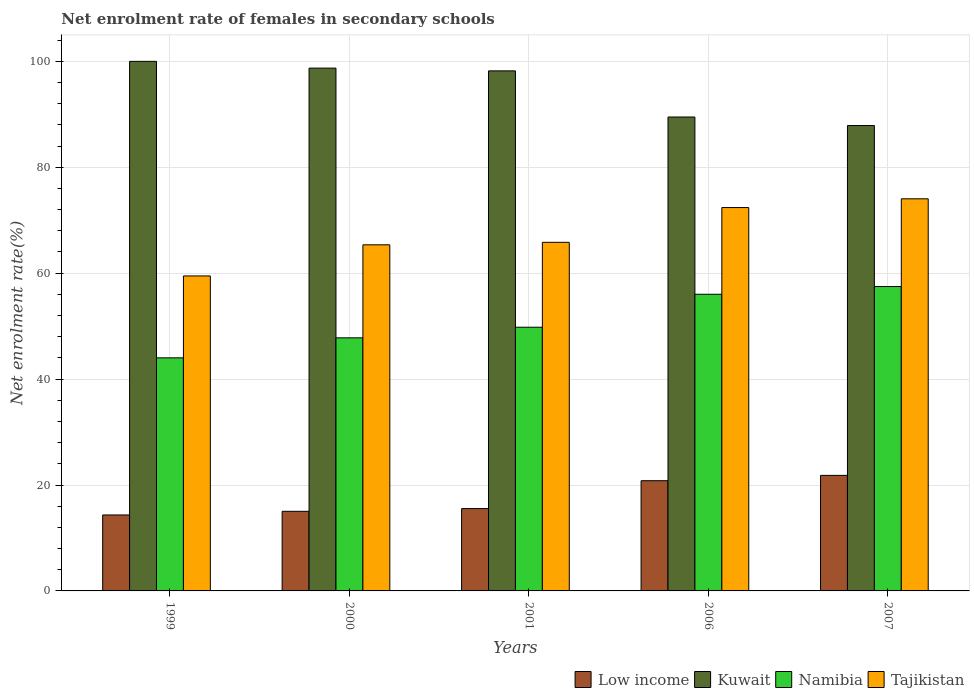How many groups of bars are there?
Make the answer very short. 5. Are the number of bars per tick equal to the number of legend labels?
Keep it short and to the point. Yes. How many bars are there on the 5th tick from the right?
Your answer should be compact. 4. In how many cases, is the number of bars for a given year not equal to the number of legend labels?
Your answer should be compact. 0. What is the net enrolment rate of females in secondary schools in Kuwait in 2006?
Ensure brevity in your answer.  89.49. Across all years, what is the maximum net enrolment rate of females in secondary schools in Namibia?
Keep it short and to the point. 57.48. Across all years, what is the minimum net enrolment rate of females in secondary schools in Kuwait?
Keep it short and to the point. 87.88. In which year was the net enrolment rate of females in secondary schools in Low income maximum?
Provide a succinct answer. 2007. In which year was the net enrolment rate of females in secondary schools in Kuwait minimum?
Offer a very short reply. 2007. What is the total net enrolment rate of females in secondary schools in Tajikistan in the graph?
Your answer should be very brief. 337.1. What is the difference between the net enrolment rate of females in secondary schools in Kuwait in 2001 and that in 2007?
Make the answer very short. 10.32. What is the difference between the net enrolment rate of females in secondary schools in Tajikistan in 2000 and the net enrolment rate of females in secondary schools in Namibia in 2006?
Provide a short and direct response. 9.34. What is the average net enrolment rate of females in secondary schools in Low income per year?
Ensure brevity in your answer.  17.51. In the year 2001, what is the difference between the net enrolment rate of females in secondary schools in Kuwait and net enrolment rate of females in secondary schools in Namibia?
Your answer should be compact. 48.41. In how many years, is the net enrolment rate of females in secondary schools in Namibia greater than 72 %?
Your answer should be very brief. 0. What is the ratio of the net enrolment rate of females in secondary schools in Kuwait in 2000 to that in 2007?
Give a very brief answer. 1.12. What is the difference between the highest and the second highest net enrolment rate of females in secondary schools in Low income?
Your response must be concise. 1.01. What is the difference between the highest and the lowest net enrolment rate of females in secondary schools in Low income?
Give a very brief answer. 7.47. What does the 2nd bar from the left in 2007 represents?
Your answer should be very brief. Kuwait. What does the 1st bar from the right in 2006 represents?
Provide a short and direct response. Tajikistan. How many bars are there?
Offer a terse response. 20. Are all the bars in the graph horizontal?
Provide a succinct answer. No. How many years are there in the graph?
Make the answer very short. 5. Where does the legend appear in the graph?
Provide a succinct answer. Bottom right. How are the legend labels stacked?
Your answer should be very brief. Horizontal. What is the title of the graph?
Provide a succinct answer. Net enrolment rate of females in secondary schools. What is the label or title of the Y-axis?
Your response must be concise. Net enrolment rate(%). What is the Net enrolment rate(%) of Low income in 1999?
Provide a succinct answer. 14.35. What is the Net enrolment rate(%) in Kuwait in 1999?
Offer a terse response. 100. What is the Net enrolment rate(%) of Namibia in 1999?
Your response must be concise. 44.01. What is the Net enrolment rate(%) of Tajikistan in 1999?
Offer a terse response. 59.48. What is the Net enrolment rate(%) in Low income in 2000?
Offer a terse response. 15.03. What is the Net enrolment rate(%) of Kuwait in 2000?
Offer a terse response. 98.72. What is the Net enrolment rate(%) in Namibia in 2000?
Ensure brevity in your answer.  47.79. What is the Net enrolment rate(%) in Tajikistan in 2000?
Ensure brevity in your answer.  65.36. What is the Net enrolment rate(%) in Low income in 2001?
Make the answer very short. 15.55. What is the Net enrolment rate(%) of Kuwait in 2001?
Your answer should be very brief. 98.2. What is the Net enrolment rate(%) in Namibia in 2001?
Provide a succinct answer. 49.79. What is the Net enrolment rate(%) of Tajikistan in 2001?
Provide a succinct answer. 65.83. What is the Net enrolment rate(%) of Low income in 2006?
Ensure brevity in your answer.  20.81. What is the Net enrolment rate(%) of Kuwait in 2006?
Make the answer very short. 89.49. What is the Net enrolment rate(%) in Namibia in 2006?
Make the answer very short. 56.02. What is the Net enrolment rate(%) in Tajikistan in 2006?
Your answer should be compact. 72.39. What is the Net enrolment rate(%) in Low income in 2007?
Your answer should be compact. 21.82. What is the Net enrolment rate(%) in Kuwait in 2007?
Your answer should be very brief. 87.88. What is the Net enrolment rate(%) in Namibia in 2007?
Ensure brevity in your answer.  57.48. What is the Net enrolment rate(%) in Tajikistan in 2007?
Give a very brief answer. 74.05. Across all years, what is the maximum Net enrolment rate(%) in Low income?
Give a very brief answer. 21.82. Across all years, what is the maximum Net enrolment rate(%) in Namibia?
Offer a very short reply. 57.48. Across all years, what is the maximum Net enrolment rate(%) in Tajikistan?
Your answer should be very brief. 74.05. Across all years, what is the minimum Net enrolment rate(%) of Low income?
Your answer should be compact. 14.35. Across all years, what is the minimum Net enrolment rate(%) of Kuwait?
Keep it short and to the point. 87.88. Across all years, what is the minimum Net enrolment rate(%) in Namibia?
Your answer should be very brief. 44.01. Across all years, what is the minimum Net enrolment rate(%) in Tajikistan?
Your answer should be compact. 59.48. What is the total Net enrolment rate(%) of Low income in the graph?
Your answer should be very brief. 87.56. What is the total Net enrolment rate(%) of Kuwait in the graph?
Give a very brief answer. 474.3. What is the total Net enrolment rate(%) in Namibia in the graph?
Offer a terse response. 255.1. What is the total Net enrolment rate(%) of Tajikistan in the graph?
Offer a very short reply. 337.1. What is the difference between the Net enrolment rate(%) in Low income in 1999 and that in 2000?
Your answer should be very brief. -0.69. What is the difference between the Net enrolment rate(%) of Kuwait in 1999 and that in 2000?
Provide a short and direct response. 1.28. What is the difference between the Net enrolment rate(%) of Namibia in 1999 and that in 2000?
Provide a succinct answer. -3.78. What is the difference between the Net enrolment rate(%) of Tajikistan in 1999 and that in 2000?
Provide a short and direct response. -5.88. What is the difference between the Net enrolment rate(%) of Low income in 1999 and that in 2001?
Offer a terse response. -1.2. What is the difference between the Net enrolment rate(%) in Kuwait in 1999 and that in 2001?
Provide a succinct answer. 1.8. What is the difference between the Net enrolment rate(%) in Namibia in 1999 and that in 2001?
Your answer should be very brief. -5.78. What is the difference between the Net enrolment rate(%) in Tajikistan in 1999 and that in 2001?
Your answer should be compact. -6.35. What is the difference between the Net enrolment rate(%) of Low income in 1999 and that in 2006?
Your response must be concise. -6.47. What is the difference between the Net enrolment rate(%) of Kuwait in 1999 and that in 2006?
Make the answer very short. 10.51. What is the difference between the Net enrolment rate(%) in Namibia in 1999 and that in 2006?
Your answer should be very brief. -12. What is the difference between the Net enrolment rate(%) in Tajikistan in 1999 and that in 2006?
Your answer should be compact. -12.91. What is the difference between the Net enrolment rate(%) in Low income in 1999 and that in 2007?
Your response must be concise. -7.47. What is the difference between the Net enrolment rate(%) of Kuwait in 1999 and that in 2007?
Offer a very short reply. 12.12. What is the difference between the Net enrolment rate(%) of Namibia in 1999 and that in 2007?
Your answer should be very brief. -13.46. What is the difference between the Net enrolment rate(%) in Tajikistan in 1999 and that in 2007?
Your answer should be very brief. -14.57. What is the difference between the Net enrolment rate(%) in Low income in 2000 and that in 2001?
Your answer should be compact. -0.52. What is the difference between the Net enrolment rate(%) of Kuwait in 2000 and that in 2001?
Give a very brief answer. 0.52. What is the difference between the Net enrolment rate(%) in Namibia in 2000 and that in 2001?
Keep it short and to the point. -2. What is the difference between the Net enrolment rate(%) of Tajikistan in 2000 and that in 2001?
Make the answer very short. -0.47. What is the difference between the Net enrolment rate(%) of Low income in 2000 and that in 2006?
Give a very brief answer. -5.78. What is the difference between the Net enrolment rate(%) in Kuwait in 2000 and that in 2006?
Keep it short and to the point. 9.23. What is the difference between the Net enrolment rate(%) in Namibia in 2000 and that in 2006?
Your answer should be very brief. -8.23. What is the difference between the Net enrolment rate(%) of Tajikistan in 2000 and that in 2006?
Your answer should be very brief. -7.04. What is the difference between the Net enrolment rate(%) of Low income in 2000 and that in 2007?
Keep it short and to the point. -6.79. What is the difference between the Net enrolment rate(%) in Kuwait in 2000 and that in 2007?
Your answer should be compact. 10.84. What is the difference between the Net enrolment rate(%) in Namibia in 2000 and that in 2007?
Make the answer very short. -9.68. What is the difference between the Net enrolment rate(%) in Tajikistan in 2000 and that in 2007?
Your answer should be compact. -8.69. What is the difference between the Net enrolment rate(%) in Low income in 2001 and that in 2006?
Keep it short and to the point. -5.26. What is the difference between the Net enrolment rate(%) of Kuwait in 2001 and that in 2006?
Provide a short and direct response. 8.71. What is the difference between the Net enrolment rate(%) of Namibia in 2001 and that in 2006?
Offer a terse response. -6.22. What is the difference between the Net enrolment rate(%) of Tajikistan in 2001 and that in 2006?
Provide a succinct answer. -6.56. What is the difference between the Net enrolment rate(%) in Low income in 2001 and that in 2007?
Ensure brevity in your answer.  -6.27. What is the difference between the Net enrolment rate(%) in Kuwait in 2001 and that in 2007?
Offer a terse response. 10.32. What is the difference between the Net enrolment rate(%) in Namibia in 2001 and that in 2007?
Your response must be concise. -7.68. What is the difference between the Net enrolment rate(%) in Tajikistan in 2001 and that in 2007?
Ensure brevity in your answer.  -8.22. What is the difference between the Net enrolment rate(%) of Low income in 2006 and that in 2007?
Offer a very short reply. -1.01. What is the difference between the Net enrolment rate(%) in Kuwait in 2006 and that in 2007?
Provide a short and direct response. 1.61. What is the difference between the Net enrolment rate(%) of Namibia in 2006 and that in 2007?
Provide a succinct answer. -1.46. What is the difference between the Net enrolment rate(%) in Tajikistan in 2006 and that in 2007?
Your response must be concise. -1.65. What is the difference between the Net enrolment rate(%) in Low income in 1999 and the Net enrolment rate(%) in Kuwait in 2000?
Offer a very short reply. -84.38. What is the difference between the Net enrolment rate(%) in Low income in 1999 and the Net enrolment rate(%) in Namibia in 2000?
Your answer should be compact. -33.45. What is the difference between the Net enrolment rate(%) in Low income in 1999 and the Net enrolment rate(%) in Tajikistan in 2000?
Your answer should be compact. -51.01. What is the difference between the Net enrolment rate(%) of Kuwait in 1999 and the Net enrolment rate(%) of Namibia in 2000?
Offer a terse response. 52.21. What is the difference between the Net enrolment rate(%) in Kuwait in 1999 and the Net enrolment rate(%) in Tajikistan in 2000?
Keep it short and to the point. 34.65. What is the difference between the Net enrolment rate(%) in Namibia in 1999 and the Net enrolment rate(%) in Tajikistan in 2000?
Your response must be concise. -21.34. What is the difference between the Net enrolment rate(%) of Low income in 1999 and the Net enrolment rate(%) of Kuwait in 2001?
Offer a terse response. -83.86. What is the difference between the Net enrolment rate(%) of Low income in 1999 and the Net enrolment rate(%) of Namibia in 2001?
Provide a succinct answer. -35.45. What is the difference between the Net enrolment rate(%) in Low income in 1999 and the Net enrolment rate(%) in Tajikistan in 2001?
Your response must be concise. -51.48. What is the difference between the Net enrolment rate(%) of Kuwait in 1999 and the Net enrolment rate(%) of Namibia in 2001?
Keep it short and to the point. 50.21. What is the difference between the Net enrolment rate(%) of Kuwait in 1999 and the Net enrolment rate(%) of Tajikistan in 2001?
Give a very brief answer. 34.17. What is the difference between the Net enrolment rate(%) in Namibia in 1999 and the Net enrolment rate(%) in Tajikistan in 2001?
Your answer should be compact. -21.81. What is the difference between the Net enrolment rate(%) in Low income in 1999 and the Net enrolment rate(%) in Kuwait in 2006?
Keep it short and to the point. -75.15. What is the difference between the Net enrolment rate(%) of Low income in 1999 and the Net enrolment rate(%) of Namibia in 2006?
Provide a succinct answer. -41.67. What is the difference between the Net enrolment rate(%) in Low income in 1999 and the Net enrolment rate(%) in Tajikistan in 2006?
Offer a very short reply. -58.05. What is the difference between the Net enrolment rate(%) of Kuwait in 1999 and the Net enrolment rate(%) of Namibia in 2006?
Keep it short and to the point. 43.98. What is the difference between the Net enrolment rate(%) in Kuwait in 1999 and the Net enrolment rate(%) in Tajikistan in 2006?
Provide a succinct answer. 27.61. What is the difference between the Net enrolment rate(%) of Namibia in 1999 and the Net enrolment rate(%) of Tajikistan in 2006?
Provide a short and direct response. -28.38. What is the difference between the Net enrolment rate(%) in Low income in 1999 and the Net enrolment rate(%) in Kuwait in 2007?
Your response must be concise. -73.54. What is the difference between the Net enrolment rate(%) in Low income in 1999 and the Net enrolment rate(%) in Namibia in 2007?
Keep it short and to the point. -43.13. What is the difference between the Net enrolment rate(%) of Low income in 1999 and the Net enrolment rate(%) of Tajikistan in 2007?
Make the answer very short. -59.7. What is the difference between the Net enrolment rate(%) of Kuwait in 1999 and the Net enrolment rate(%) of Namibia in 2007?
Give a very brief answer. 42.52. What is the difference between the Net enrolment rate(%) in Kuwait in 1999 and the Net enrolment rate(%) in Tajikistan in 2007?
Ensure brevity in your answer.  25.95. What is the difference between the Net enrolment rate(%) in Namibia in 1999 and the Net enrolment rate(%) in Tajikistan in 2007?
Your answer should be very brief. -30.03. What is the difference between the Net enrolment rate(%) of Low income in 2000 and the Net enrolment rate(%) of Kuwait in 2001?
Your answer should be very brief. -83.17. What is the difference between the Net enrolment rate(%) in Low income in 2000 and the Net enrolment rate(%) in Namibia in 2001?
Your answer should be compact. -34.76. What is the difference between the Net enrolment rate(%) of Low income in 2000 and the Net enrolment rate(%) of Tajikistan in 2001?
Provide a succinct answer. -50.79. What is the difference between the Net enrolment rate(%) in Kuwait in 2000 and the Net enrolment rate(%) in Namibia in 2001?
Ensure brevity in your answer.  48.93. What is the difference between the Net enrolment rate(%) of Kuwait in 2000 and the Net enrolment rate(%) of Tajikistan in 2001?
Provide a short and direct response. 32.9. What is the difference between the Net enrolment rate(%) of Namibia in 2000 and the Net enrolment rate(%) of Tajikistan in 2001?
Provide a succinct answer. -18.04. What is the difference between the Net enrolment rate(%) of Low income in 2000 and the Net enrolment rate(%) of Kuwait in 2006?
Provide a succinct answer. -74.46. What is the difference between the Net enrolment rate(%) in Low income in 2000 and the Net enrolment rate(%) in Namibia in 2006?
Offer a very short reply. -40.99. What is the difference between the Net enrolment rate(%) in Low income in 2000 and the Net enrolment rate(%) in Tajikistan in 2006?
Keep it short and to the point. -57.36. What is the difference between the Net enrolment rate(%) in Kuwait in 2000 and the Net enrolment rate(%) in Namibia in 2006?
Your response must be concise. 42.7. What is the difference between the Net enrolment rate(%) of Kuwait in 2000 and the Net enrolment rate(%) of Tajikistan in 2006?
Offer a terse response. 26.33. What is the difference between the Net enrolment rate(%) in Namibia in 2000 and the Net enrolment rate(%) in Tajikistan in 2006?
Provide a short and direct response. -24.6. What is the difference between the Net enrolment rate(%) of Low income in 2000 and the Net enrolment rate(%) of Kuwait in 2007?
Your response must be concise. -72.85. What is the difference between the Net enrolment rate(%) in Low income in 2000 and the Net enrolment rate(%) in Namibia in 2007?
Offer a very short reply. -42.44. What is the difference between the Net enrolment rate(%) of Low income in 2000 and the Net enrolment rate(%) of Tajikistan in 2007?
Offer a terse response. -59.01. What is the difference between the Net enrolment rate(%) in Kuwait in 2000 and the Net enrolment rate(%) in Namibia in 2007?
Your answer should be very brief. 41.25. What is the difference between the Net enrolment rate(%) of Kuwait in 2000 and the Net enrolment rate(%) of Tajikistan in 2007?
Offer a very short reply. 24.68. What is the difference between the Net enrolment rate(%) in Namibia in 2000 and the Net enrolment rate(%) in Tajikistan in 2007?
Keep it short and to the point. -26.25. What is the difference between the Net enrolment rate(%) of Low income in 2001 and the Net enrolment rate(%) of Kuwait in 2006?
Offer a terse response. -73.94. What is the difference between the Net enrolment rate(%) of Low income in 2001 and the Net enrolment rate(%) of Namibia in 2006?
Make the answer very short. -40.47. What is the difference between the Net enrolment rate(%) of Low income in 2001 and the Net enrolment rate(%) of Tajikistan in 2006?
Make the answer very short. -56.84. What is the difference between the Net enrolment rate(%) of Kuwait in 2001 and the Net enrolment rate(%) of Namibia in 2006?
Give a very brief answer. 42.18. What is the difference between the Net enrolment rate(%) of Kuwait in 2001 and the Net enrolment rate(%) of Tajikistan in 2006?
Your answer should be very brief. 25.81. What is the difference between the Net enrolment rate(%) of Namibia in 2001 and the Net enrolment rate(%) of Tajikistan in 2006?
Ensure brevity in your answer.  -22.6. What is the difference between the Net enrolment rate(%) of Low income in 2001 and the Net enrolment rate(%) of Kuwait in 2007?
Keep it short and to the point. -72.33. What is the difference between the Net enrolment rate(%) in Low income in 2001 and the Net enrolment rate(%) in Namibia in 2007?
Ensure brevity in your answer.  -41.93. What is the difference between the Net enrolment rate(%) in Low income in 2001 and the Net enrolment rate(%) in Tajikistan in 2007?
Make the answer very short. -58.5. What is the difference between the Net enrolment rate(%) in Kuwait in 2001 and the Net enrolment rate(%) in Namibia in 2007?
Offer a very short reply. 40.73. What is the difference between the Net enrolment rate(%) in Kuwait in 2001 and the Net enrolment rate(%) in Tajikistan in 2007?
Keep it short and to the point. 24.16. What is the difference between the Net enrolment rate(%) in Namibia in 2001 and the Net enrolment rate(%) in Tajikistan in 2007?
Your response must be concise. -24.25. What is the difference between the Net enrolment rate(%) of Low income in 2006 and the Net enrolment rate(%) of Kuwait in 2007?
Make the answer very short. -67.07. What is the difference between the Net enrolment rate(%) in Low income in 2006 and the Net enrolment rate(%) in Namibia in 2007?
Keep it short and to the point. -36.66. What is the difference between the Net enrolment rate(%) of Low income in 2006 and the Net enrolment rate(%) of Tajikistan in 2007?
Offer a very short reply. -53.23. What is the difference between the Net enrolment rate(%) of Kuwait in 2006 and the Net enrolment rate(%) of Namibia in 2007?
Provide a succinct answer. 32.02. What is the difference between the Net enrolment rate(%) in Kuwait in 2006 and the Net enrolment rate(%) in Tajikistan in 2007?
Ensure brevity in your answer.  15.45. What is the difference between the Net enrolment rate(%) of Namibia in 2006 and the Net enrolment rate(%) of Tajikistan in 2007?
Offer a terse response. -18.03. What is the average Net enrolment rate(%) of Low income per year?
Keep it short and to the point. 17.51. What is the average Net enrolment rate(%) in Kuwait per year?
Keep it short and to the point. 94.86. What is the average Net enrolment rate(%) of Namibia per year?
Your response must be concise. 51.02. What is the average Net enrolment rate(%) of Tajikistan per year?
Give a very brief answer. 67.42. In the year 1999, what is the difference between the Net enrolment rate(%) in Low income and Net enrolment rate(%) in Kuwait?
Offer a terse response. -85.66. In the year 1999, what is the difference between the Net enrolment rate(%) of Low income and Net enrolment rate(%) of Namibia?
Offer a very short reply. -29.67. In the year 1999, what is the difference between the Net enrolment rate(%) of Low income and Net enrolment rate(%) of Tajikistan?
Your answer should be compact. -45.13. In the year 1999, what is the difference between the Net enrolment rate(%) of Kuwait and Net enrolment rate(%) of Namibia?
Make the answer very short. 55.99. In the year 1999, what is the difference between the Net enrolment rate(%) of Kuwait and Net enrolment rate(%) of Tajikistan?
Make the answer very short. 40.52. In the year 1999, what is the difference between the Net enrolment rate(%) in Namibia and Net enrolment rate(%) in Tajikistan?
Your answer should be very brief. -15.46. In the year 2000, what is the difference between the Net enrolment rate(%) of Low income and Net enrolment rate(%) of Kuwait?
Keep it short and to the point. -83.69. In the year 2000, what is the difference between the Net enrolment rate(%) of Low income and Net enrolment rate(%) of Namibia?
Keep it short and to the point. -32.76. In the year 2000, what is the difference between the Net enrolment rate(%) of Low income and Net enrolment rate(%) of Tajikistan?
Make the answer very short. -50.32. In the year 2000, what is the difference between the Net enrolment rate(%) of Kuwait and Net enrolment rate(%) of Namibia?
Your answer should be compact. 50.93. In the year 2000, what is the difference between the Net enrolment rate(%) in Kuwait and Net enrolment rate(%) in Tajikistan?
Offer a terse response. 33.37. In the year 2000, what is the difference between the Net enrolment rate(%) in Namibia and Net enrolment rate(%) in Tajikistan?
Your response must be concise. -17.56. In the year 2001, what is the difference between the Net enrolment rate(%) of Low income and Net enrolment rate(%) of Kuwait?
Your answer should be very brief. -82.65. In the year 2001, what is the difference between the Net enrolment rate(%) in Low income and Net enrolment rate(%) in Namibia?
Offer a terse response. -34.25. In the year 2001, what is the difference between the Net enrolment rate(%) of Low income and Net enrolment rate(%) of Tajikistan?
Provide a succinct answer. -50.28. In the year 2001, what is the difference between the Net enrolment rate(%) in Kuwait and Net enrolment rate(%) in Namibia?
Make the answer very short. 48.41. In the year 2001, what is the difference between the Net enrolment rate(%) in Kuwait and Net enrolment rate(%) in Tajikistan?
Offer a terse response. 32.38. In the year 2001, what is the difference between the Net enrolment rate(%) in Namibia and Net enrolment rate(%) in Tajikistan?
Provide a succinct answer. -16.03. In the year 2006, what is the difference between the Net enrolment rate(%) in Low income and Net enrolment rate(%) in Kuwait?
Offer a terse response. -68.68. In the year 2006, what is the difference between the Net enrolment rate(%) in Low income and Net enrolment rate(%) in Namibia?
Your answer should be very brief. -35.21. In the year 2006, what is the difference between the Net enrolment rate(%) in Low income and Net enrolment rate(%) in Tajikistan?
Offer a terse response. -51.58. In the year 2006, what is the difference between the Net enrolment rate(%) in Kuwait and Net enrolment rate(%) in Namibia?
Provide a short and direct response. 33.47. In the year 2006, what is the difference between the Net enrolment rate(%) in Kuwait and Net enrolment rate(%) in Tajikistan?
Make the answer very short. 17.1. In the year 2006, what is the difference between the Net enrolment rate(%) of Namibia and Net enrolment rate(%) of Tajikistan?
Your answer should be compact. -16.37. In the year 2007, what is the difference between the Net enrolment rate(%) in Low income and Net enrolment rate(%) in Kuwait?
Give a very brief answer. -66.06. In the year 2007, what is the difference between the Net enrolment rate(%) in Low income and Net enrolment rate(%) in Namibia?
Your response must be concise. -35.66. In the year 2007, what is the difference between the Net enrolment rate(%) of Low income and Net enrolment rate(%) of Tajikistan?
Your answer should be compact. -52.23. In the year 2007, what is the difference between the Net enrolment rate(%) in Kuwait and Net enrolment rate(%) in Namibia?
Provide a succinct answer. 30.41. In the year 2007, what is the difference between the Net enrolment rate(%) in Kuwait and Net enrolment rate(%) in Tajikistan?
Your answer should be very brief. 13.84. In the year 2007, what is the difference between the Net enrolment rate(%) in Namibia and Net enrolment rate(%) in Tajikistan?
Your answer should be very brief. -16.57. What is the ratio of the Net enrolment rate(%) in Low income in 1999 to that in 2000?
Keep it short and to the point. 0.95. What is the ratio of the Net enrolment rate(%) in Kuwait in 1999 to that in 2000?
Give a very brief answer. 1.01. What is the ratio of the Net enrolment rate(%) of Namibia in 1999 to that in 2000?
Provide a short and direct response. 0.92. What is the ratio of the Net enrolment rate(%) of Tajikistan in 1999 to that in 2000?
Give a very brief answer. 0.91. What is the ratio of the Net enrolment rate(%) in Low income in 1999 to that in 2001?
Your answer should be compact. 0.92. What is the ratio of the Net enrolment rate(%) of Kuwait in 1999 to that in 2001?
Your response must be concise. 1.02. What is the ratio of the Net enrolment rate(%) in Namibia in 1999 to that in 2001?
Your response must be concise. 0.88. What is the ratio of the Net enrolment rate(%) in Tajikistan in 1999 to that in 2001?
Offer a terse response. 0.9. What is the ratio of the Net enrolment rate(%) of Low income in 1999 to that in 2006?
Offer a terse response. 0.69. What is the ratio of the Net enrolment rate(%) in Kuwait in 1999 to that in 2006?
Your answer should be very brief. 1.12. What is the ratio of the Net enrolment rate(%) in Namibia in 1999 to that in 2006?
Provide a succinct answer. 0.79. What is the ratio of the Net enrolment rate(%) in Tajikistan in 1999 to that in 2006?
Provide a succinct answer. 0.82. What is the ratio of the Net enrolment rate(%) in Low income in 1999 to that in 2007?
Offer a very short reply. 0.66. What is the ratio of the Net enrolment rate(%) of Kuwait in 1999 to that in 2007?
Your response must be concise. 1.14. What is the ratio of the Net enrolment rate(%) of Namibia in 1999 to that in 2007?
Provide a short and direct response. 0.77. What is the ratio of the Net enrolment rate(%) in Tajikistan in 1999 to that in 2007?
Provide a succinct answer. 0.8. What is the ratio of the Net enrolment rate(%) of Low income in 2000 to that in 2001?
Keep it short and to the point. 0.97. What is the ratio of the Net enrolment rate(%) of Namibia in 2000 to that in 2001?
Offer a terse response. 0.96. What is the ratio of the Net enrolment rate(%) of Low income in 2000 to that in 2006?
Your answer should be very brief. 0.72. What is the ratio of the Net enrolment rate(%) in Kuwait in 2000 to that in 2006?
Make the answer very short. 1.1. What is the ratio of the Net enrolment rate(%) of Namibia in 2000 to that in 2006?
Provide a short and direct response. 0.85. What is the ratio of the Net enrolment rate(%) in Tajikistan in 2000 to that in 2006?
Keep it short and to the point. 0.9. What is the ratio of the Net enrolment rate(%) of Low income in 2000 to that in 2007?
Offer a terse response. 0.69. What is the ratio of the Net enrolment rate(%) in Kuwait in 2000 to that in 2007?
Provide a succinct answer. 1.12. What is the ratio of the Net enrolment rate(%) of Namibia in 2000 to that in 2007?
Give a very brief answer. 0.83. What is the ratio of the Net enrolment rate(%) of Tajikistan in 2000 to that in 2007?
Offer a terse response. 0.88. What is the ratio of the Net enrolment rate(%) of Low income in 2001 to that in 2006?
Ensure brevity in your answer.  0.75. What is the ratio of the Net enrolment rate(%) of Kuwait in 2001 to that in 2006?
Ensure brevity in your answer.  1.1. What is the ratio of the Net enrolment rate(%) in Tajikistan in 2001 to that in 2006?
Make the answer very short. 0.91. What is the ratio of the Net enrolment rate(%) of Low income in 2001 to that in 2007?
Your response must be concise. 0.71. What is the ratio of the Net enrolment rate(%) in Kuwait in 2001 to that in 2007?
Provide a succinct answer. 1.12. What is the ratio of the Net enrolment rate(%) in Namibia in 2001 to that in 2007?
Give a very brief answer. 0.87. What is the ratio of the Net enrolment rate(%) in Tajikistan in 2001 to that in 2007?
Your answer should be very brief. 0.89. What is the ratio of the Net enrolment rate(%) of Low income in 2006 to that in 2007?
Your response must be concise. 0.95. What is the ratio of the Net enrolment rate(%) in Kuwait in 2006 to that in 2007?
Your response must be concise. 1.02. What is the ratio of the Net enrolment rate(%) in Namibia in 2006 to that in 2007?
Your answer should be compact. 0.97. What is the ratio of the Net enrolment rate(%) in Tajikistan in 2006 to that in 2007?
Give a very brief answer. 0.98. What is the difference between the highest and the second highest Net enrolment rate(%) in Kuwait?
Provide a short and direct response. 1.28. What is the difference between the highest and the second highest Net enrolment rate(%) of Namibia?
Your answer should be compact. 1.46. What is the difference between the highest and the second highest Net enrolment rate(%) of Tajikistan?
Your answer should be very brief. 1.65. What is the difference between the highest and the lowest Net enrolment rate(%) in Low income?
Give a very brief answer. 7.47. What is the difference between the highest and the lowest Net enrolment rate(%) in Kuwait?
Your response must be concise. 12.12. What is the difference between the highest and the lowest Net enrolment rate(%) in Namibia?
Give a very brief answer. 13.46. What is the difference between the highest and the lowest Net enrolment rate(%) of Tajikistan?
Offer a terse response. 14.57. 